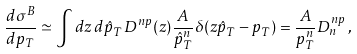<formula> <loc_0><loc_0><loc_500><loc_500>\frac { d \sigma ^ { B } } { d p _ { T } } \simeq \int d z \, d \hat { p } _ { T } \, D ^ { n p } ( z ) \frac { A } { \hat { p } _ { T } ^ { n } } \delta ( z \hat { p } _ { T } - p _ { T } ) = \frac { A } { p _ { T } ^ { n } } D _ { n } ^ { n p } \, ,</formula> 